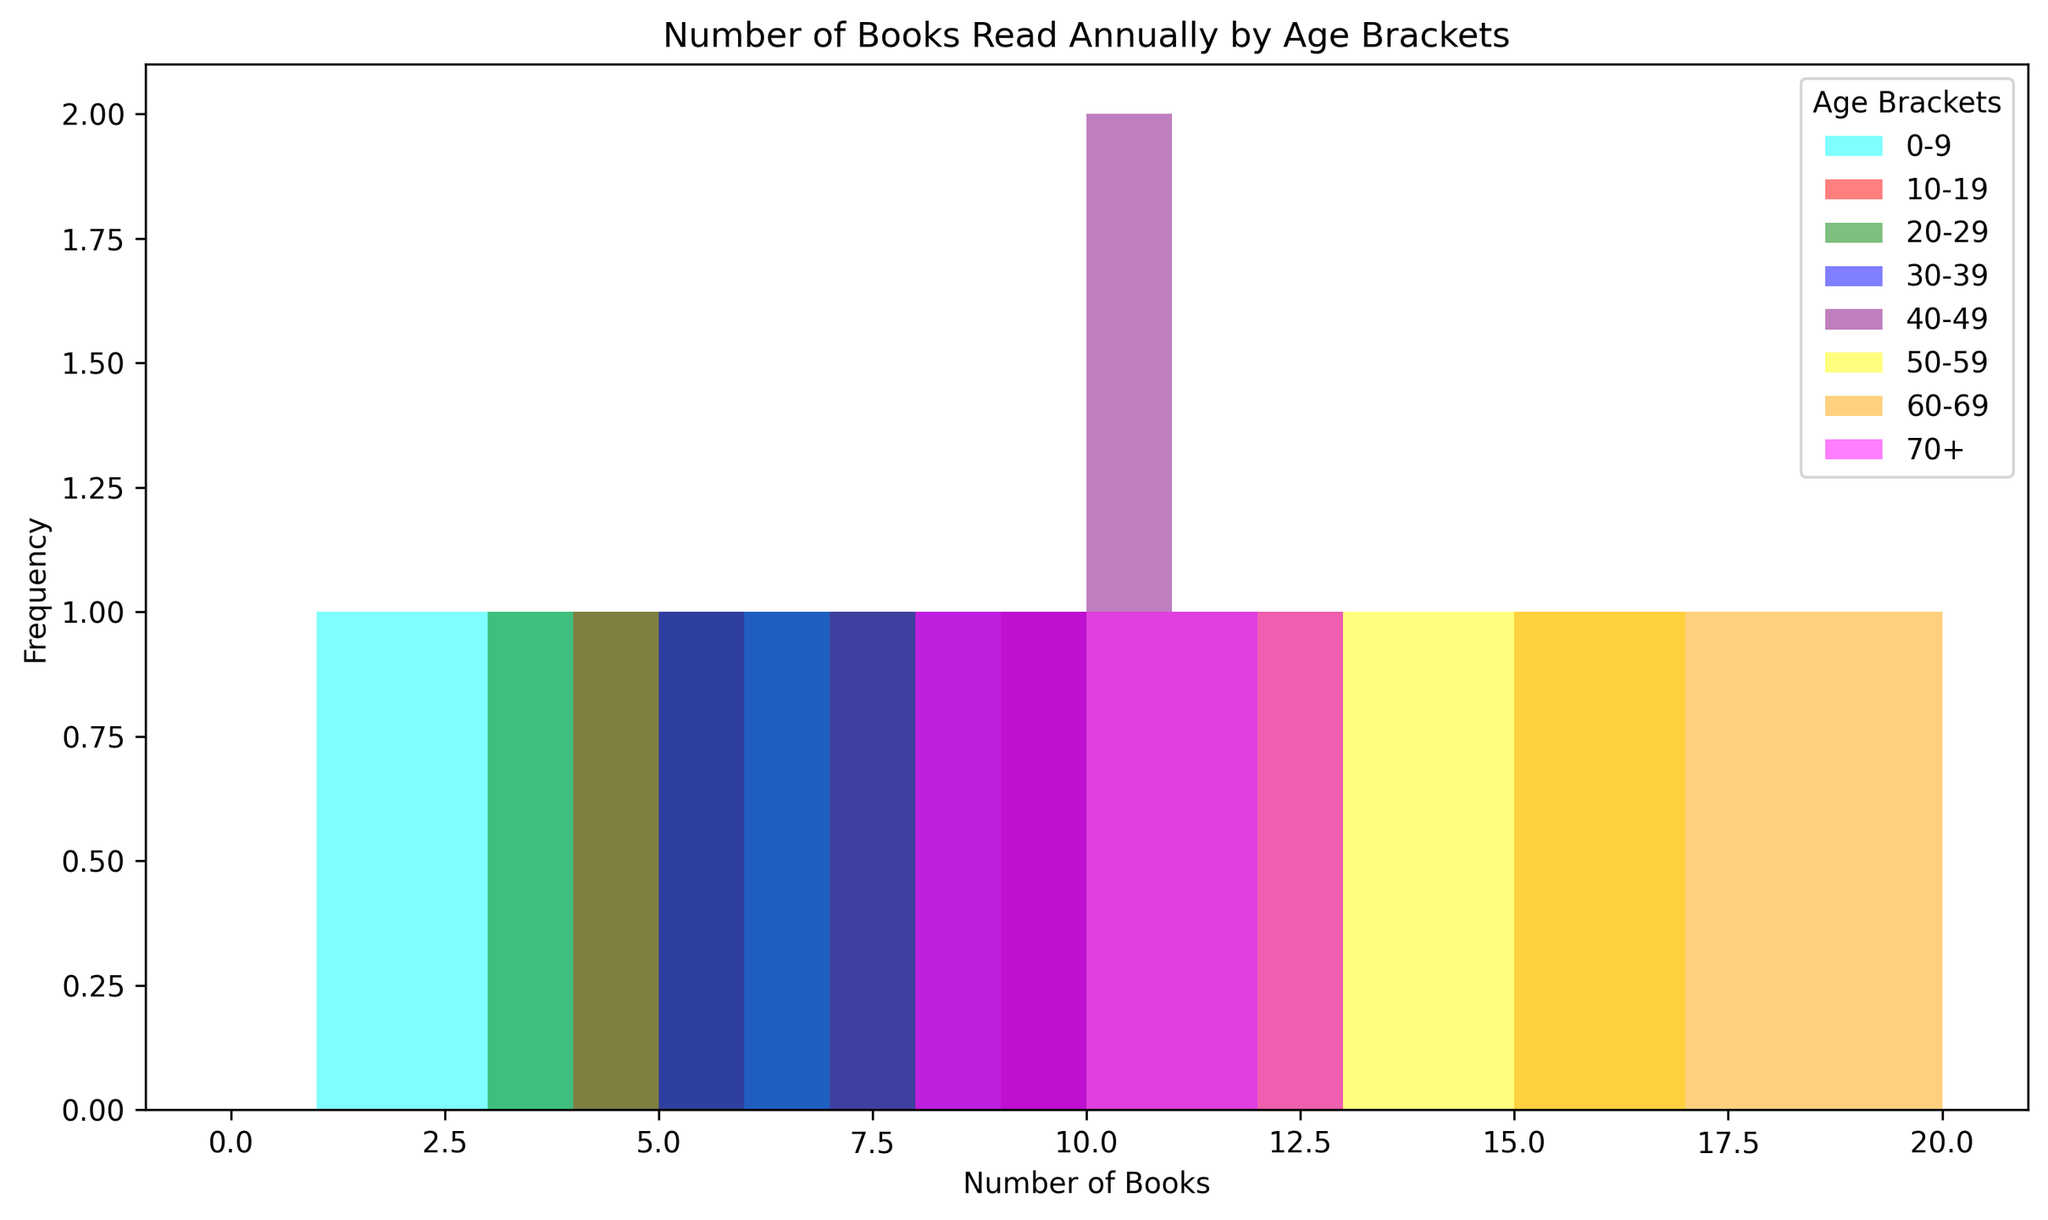Which age bracket reads the most books annually? The visually highest bars represent the frequency of books read by the '60-69' age bracket, indicating they read the most books annually.
Answer: 60-69 Between the 30-39 and 50-59 age brackets, which one tends to read more books? By comparing the height of the histograms, the '50-59' age bracket has taller bars shifted toward higher book counts, indicating they tend to read more books.
Answer: 50-59 How many age brackets have individuals that read more than 15 books annually? By analyzing the bins, only the '60-69' and '50-59' age brackets show any frequency for book counts over 15 annually.
Answer: 2 Which age bracket has the most consistent reading frequency? By checking the spread and uniformity of the histogram bars, the '0-9' age bracket shows a more uniform and consistent pattern, with bars being closer in height.
Answer: 0-9 Is there an age bracket with a reading pattern that focuses on fewer ranges? The '0-9' age bracket has histograms grouped closely and shorter range (1-6 books), illustrating a restricted reading range.
Answer: 0-9 What is the average number of books read by the '30-39' age bracket? Summing the books in '30-39' (5+6+7+8+9=35) and dividing by 5 (number of data points), the average is 35/5 = 7.
Answer: 7 Compare the reading patterns of '10-19' and '70+' age brackets. Which one has higher variance in the number of books read? The '10-19' age bracket spans from 4 to 9 books while the '70+' spans from 8 to 12 books. The '10-19' bracket shows a wider range, indicating a higher variance.
Answer: 10-19 Which colored bars represent the '20-29' age bracket, and what does this color imply? The green bars represent the '20-29' age bracket. Green implies that this is part of the mid-age group's reading pattern.
Answer: Green 